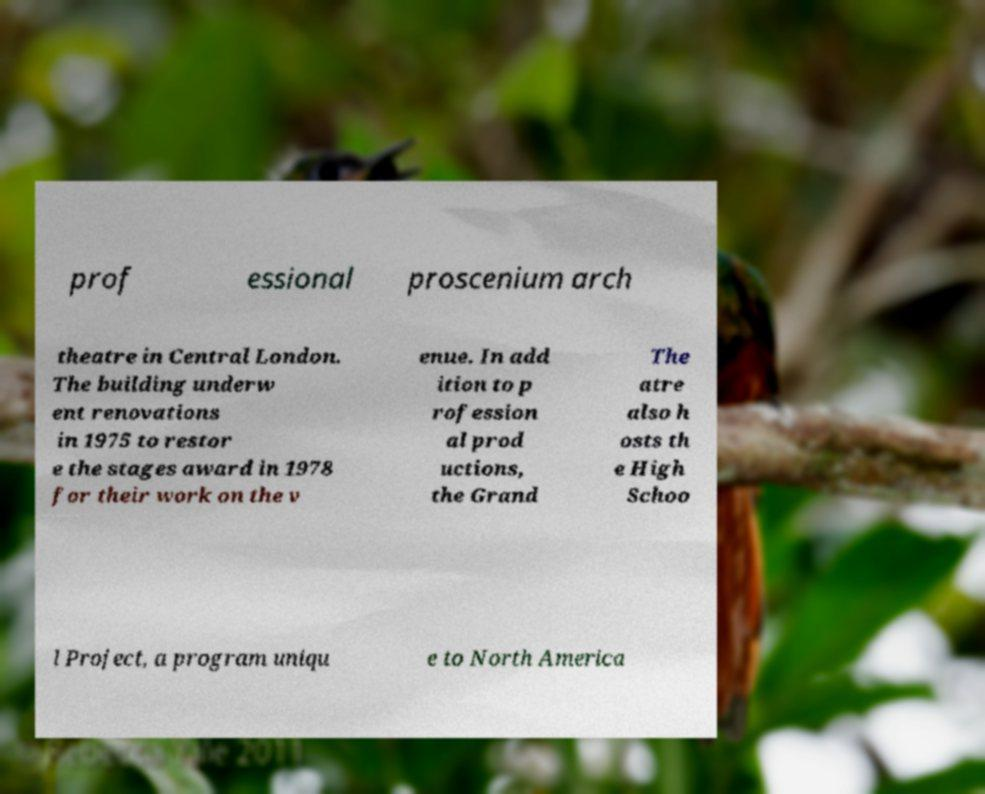Please identify and transcribe the text found in this image. prof essional proscenium arch theatre in Central London. The building underw ent renovations in 1975 to restor e the stages award in 1978 for their work on the v enue. In add ition to p rofession al prod uctions, the Grand The atre also h osts th e High Schoo l Project, a program uniqu e to North America 